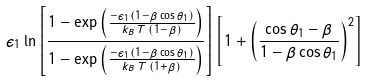<formula> <loc_0><loc_0><loc_500><loc_500>\epsilon _ { 1 } \ln \left [ \frac { 1 - \exp \left ( \frac { - \epsilon _ { 1 } ( 1 - \beta \cos \theta _ { 1 } ) } { k _ { B } \, T \, ( 1 - \beta ) } \right ) } { 1 - \exp \left ( \frac { - \epsilon _ { 1 } ( 1 - \beta \cos \theta _ { 1 } ) } { k _ { B } \, T \, ( 1 + \beta ) } \right ) } \right ] \left [ 1 + \left ( \frac { \cos \theta _ { 1 } - \beta } { 1 - \beta \cos \theta _ { 1 } } \right ) ^ { 2 } \right ]</formula> 